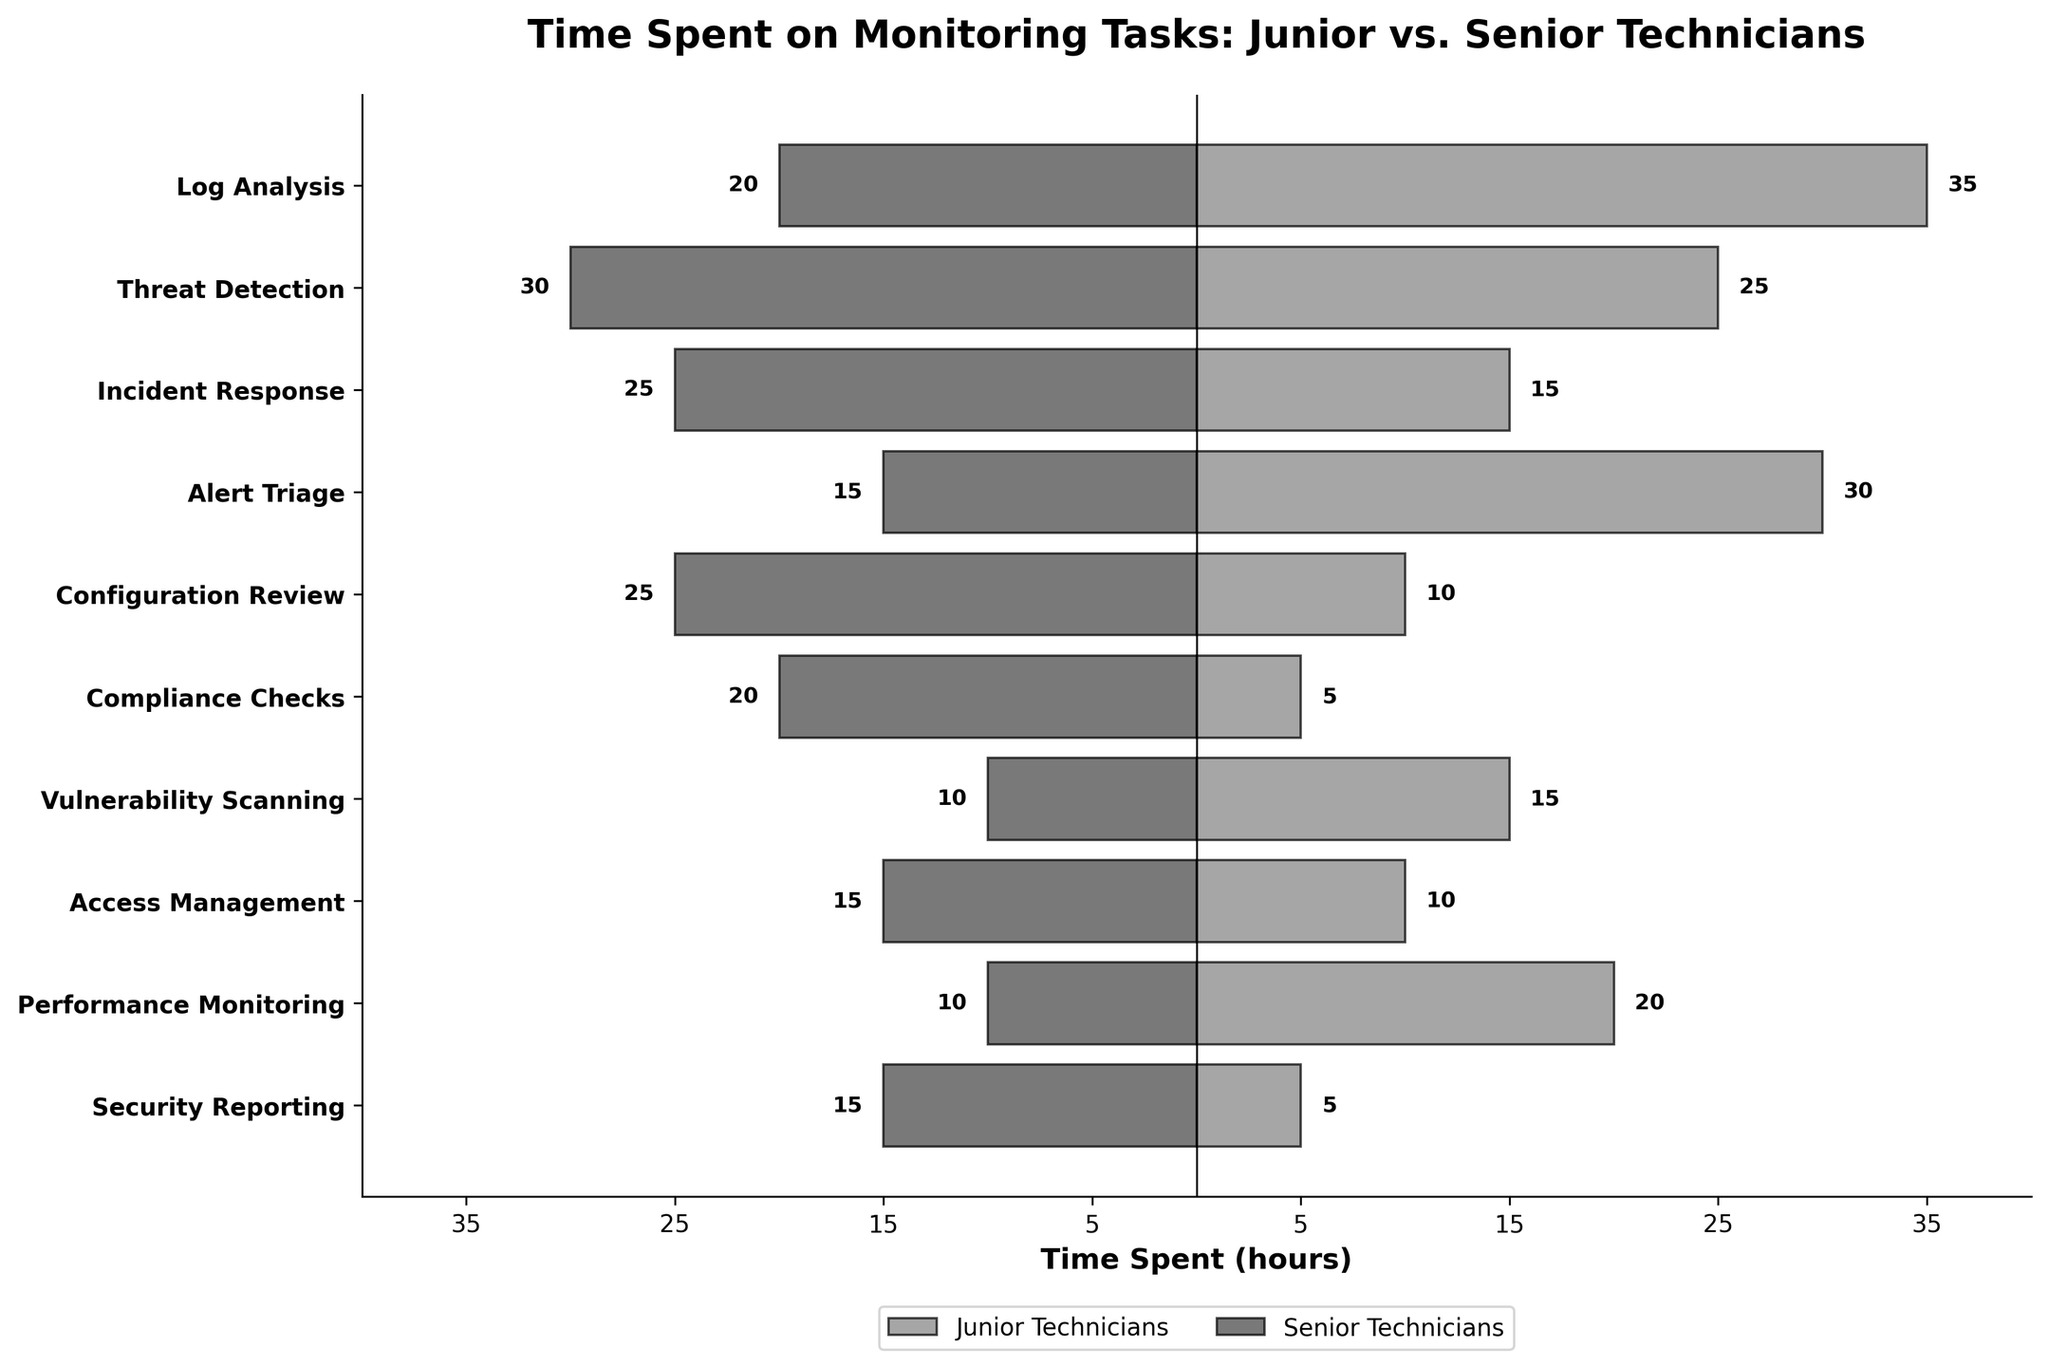What's the title of the plot? The title is located at the top of the plot and provides a description of what the figure is about.
Answer: Time Spent on Monitoring Tasks: Junior vs. Senior Technicians How many tasks are monitored according to the plot? Count the number of distinct tasks listed along the y-axis.
Answer: 10 Which task do senior technicians spend the most time on? Check which bar extends the furthest to the left for senior technicians.
Answer: Threat Detection How many more hours do junior technicians spend on Log Analysis compared to senior technicians? Find the difference between the hours spent by junior technicians and senior technicians on Log Analysis (35 - 20).
Answer: 15 hours For which task do junior technicians spend the least time? Identify the shortest bar on the right side for junior technicians.
Answer: Compliance Checks and Security Reporting What's the total time spent by senior technicians on Access Management and Performance Monitoring? Sum the time spent by senior technicians on both tasks (15 + 10).
Answer: 25 hours How does the time spent on Configuration Review compare between junior and senior technicians? Compare the lengths of the bars for junior technicians and senior technicians for Configuration Review.
Answer: Junior technicians spend less time Which task has the smallest difference in time spent between junior and senior technicians? Calculate the difference in hours for all tasks and find the smallest difference (Vulnerability Scanning: 15 - 10 = 5).
Answer: Vulnerability Scanning What's the average time spent by junior technicians on all tasks? Sum the time spent by junior technicians on all tasks and divide by the number of tasks (35+25+15+30+10+5+15+10+20+5 = 170, 170/10).
Answer: 17 hours For which tasks do junior technicians spend more time than senior technicians? Identify tasks where the bar for junior technicians is longer than that for senior technicians (Log Analysis, Alert Triage, Vulnerability Scanning, Performance Monitoring).
Answer: Log Analysis, Alert Triage, Vulnerability Scanning, Performance Monitoring 